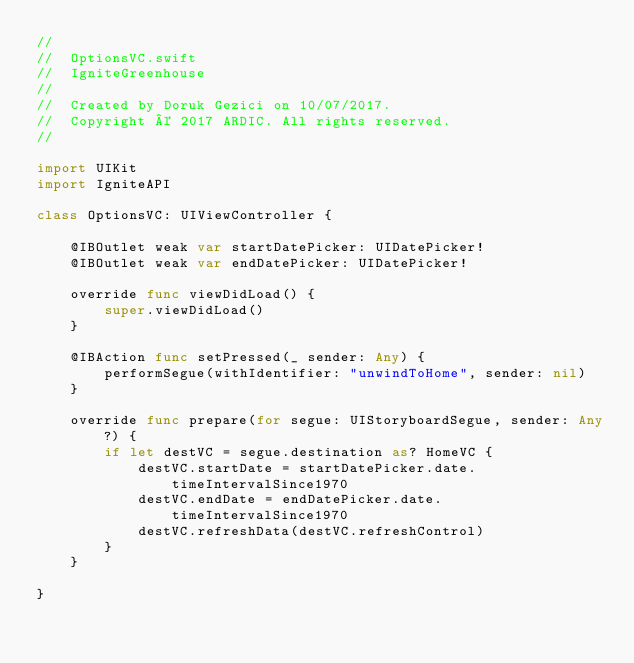Convert code to text. <code><loc_0><loc_0><loc_500><loc_500><_Swift_>//
//  OptionsVC.swift
//  IgniteGreenhouse
//
//  Created by Doruk Gezici on 10/07/2017.
//  Copyright © 2017 ARDIC. All rights reserved.
//

import UIKit
import IgniteAPI

class OptionsVC: UIViewController {
    
    @IBOutlet weak var startDatePicker: UIDatePicker!
    @IBOutlet weak var endDatePicker: UIDatePicker!

    override func viewDidLoad() {
        super.viewDidLoad()
    }

    @IBAction func setPressed(_ sender: Any) {
        performSegue(withIdentifier: "unwindToHome", sender: nil)
    }
    
    override func prepare(for segue: UIStoryboardSegue, sender: Any?) {
        if let destVC = segue.destination as? HomeVC {
            destVC.startDate = startDatePicker.date.timeIntervalSince1970
            destVC.endDate = endDatePicker.date.timeIntervalSince1970
            destVC.refreshData(destVC.refreshControl)
        }
    }
    
}
</code> 